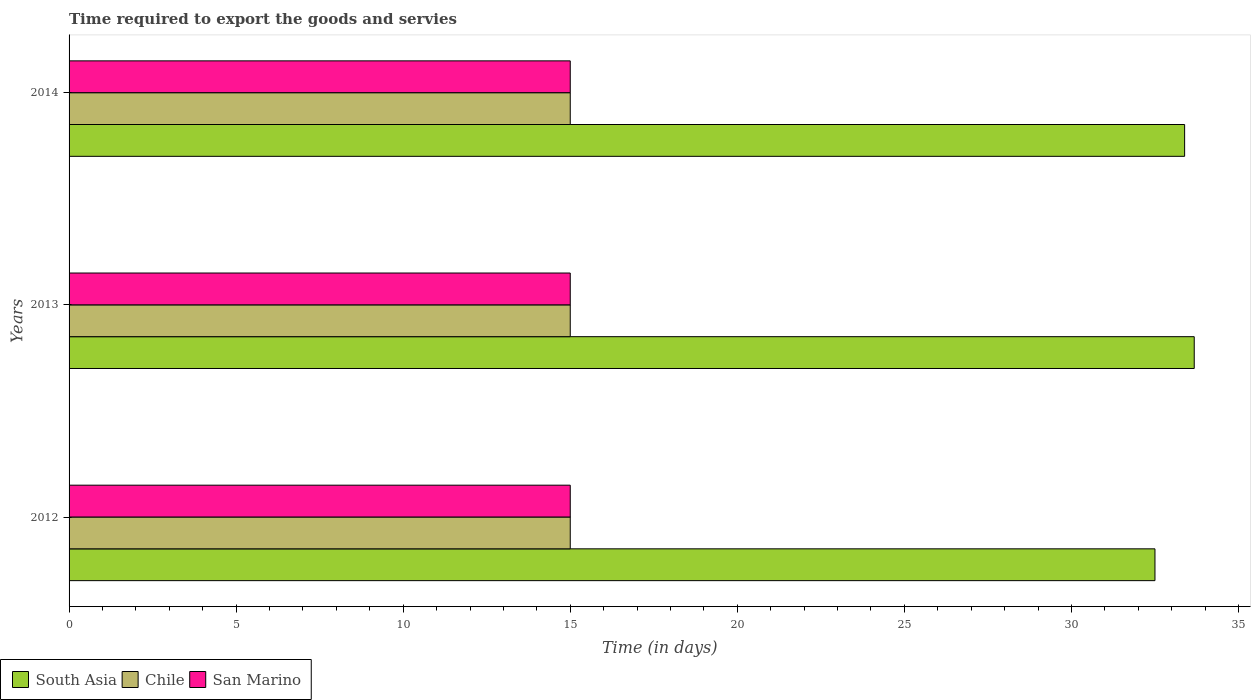How many groups of bars are there?
Keep it short and to the point. 3. Are the number of bars per tick equal to the number of legend labels?
Offer a terse response. Yes. How many bars are there on the 3rd tick from the top?
Ensure brevity in your answer.  3. In how many cases, is the number of bars for a given year not equal to the number of legend labels?
Your response must be concise. 0. What is the number of days required to export the goods and services in South Asia in 2014?
Your answer should be compact. 33.39. Across all years, what is the maximum number of days required to export the goods and services in San Marino?
Offer a terse response. 15. Across all years, what is the minimum number of days required to export the goods and services in South Asia?
Ensure brevity in your answer.  32.5. In which year was the number of days required to export the goods and services in San Marino maximum?
Keep it short and to the point. 2012. What is the difference between the number of days required to export the goods and services in South Asia in 2013 and that in 2014?
Ensure brevity in your answer.  0.29. What is the difference between the number of days required to export the goods and services in Chile in 2013 and the number of days required to export the goods and services in South Asia in 2012?
Your response must be concise. -17.5. What is the ratio of the number of days required to export the goods and services in San Marino in 2012 to that in 2014?
Provide a succinct answer. 1. Is the number of days required to export the goods and services in San Marino in 2012 less than that in 2014?
Provide a succinct answer. No. What is the difference between the highest and the second highest number of days required to export the goods and services in San Marino?
Your response must be concise. 0. What does the 1st bar from the bottom in 2013 represents?
Make the answer very short. South Asia. Are all the bars in the graph horizontal?
Offer a terse response. Yes. What is the difference between two consecutive major ticks on the X-axis?
Provide a short and direct response. 5. Does the graph contain any zero values?
Your answer should be compact. No. What is the title of the graph?
Your answer should be very brief. Time required to export the goods and servies. Does "Dominican Republic" appear as one of the legend labels in the graph?
Your answer should be very brief. No. What is the label or title of the X-axis?
Keep it short and to the point. Time (in days). What is the label or title of the Y-axis?
Offer a very short reply. Years. What is the Time (in days) in South Asia in 2012?
Offer a very short reply. 32.5. What is the Time (in days) of Chile in 2012?
Provide a short and direct response. 15. What is the Time (in days) in San Marino in 2012?
Offer a terse response. 15. What is the Time (in days) in South Asia in 2013?
Ensure brevity in your answer.  33.67. What is the Time (in days) of Chile in 2013?
Make the answer very short. 15. What is the Time (in days) of South Asia in 2014?
Keep it short and to the point. 33.39. Across all years, what is the maximum Time (in days) in South Asia?
Your response must be concise. 33.67. Across all years, what is the minimum Time (in days) in South Asia?
Provide a succinct answer. 32.5. Across all years, what is the minimum Time (in days) of San Marino?
Give a very brief answer. 15. What is the total Time (in days) of South Asia in the graph?
Provide a succinct answer. 99.56. What is the difference between the Time (in days) of South Asia in 2012 and that in 2013?
Provide a succinct answer. -1.18. What is the difference between the Time (in days) of Chile in 2012 and that in 2013?
Offer a terse response. 0. What is the difference between the Time (in days) of San Marino in 2012 and that in 2013?
Keep it short and to the point. 0. What is the difference between the Time (in days) of South Asia in 2012 and that in 2014?
Offer a terse response. -0.89. What is the difference between the Time (in days) in Chile in 2012 and that in 2014?
Your response must be concise. 0. What is the difference between the Time (in days) of South Asia in 2013 and that in 2014?
Give a very brief answer. 0.29. What is the difference between the Time (in days) in Chile in 2013 and that in 2014?
Your response must be concise. 0. What is the difference between the Time (in days) in San Marino in 2013 and that in 2014?
Offer a terse response. 0. What is the difference between the Time (in days) of South Asia in 2012 and the Time (in days) of San Marino in 2013?
Provide a succinct answer. 17.5. What is the difference between the Time (in days) in Chile in 2012 and the Time (in days) in San Marino in 2013?
Provide a short and direct response. 0. What is the difference between the Time (in days) of South Asia in 2012 and the Time (in days) of Chile in 2014?
Your response must be concise. 17.5. What is the difference between the Time (in days) in South Asia in 2013 and the Time (in days) in Chile in 2014?
Make the answer very short. 18.68. What is the difference between the Time (in days) in South Asia in 2013 and the Time (in days) in San Marino in 2014?
Ensure brevity in your answer.  18.68. What is the difference between the Time (in days) in Chile in 2013 and the Time (in days) in San Marino in 2014?
Provide a succinct answer. 0. What is the average Time (in days) in South Asia per year?
Make the answer very short. 33.19. What is the average Time (in days) of Chile per year?
Your answer should be compact. 15. What is the average Time (in days) of San Marino per year?
Your answer should be very brief. 15. In the year 2012, what is the difference between the Time (in days) in South Asia and Time (in days) in San Marino?
Provide a succinct answer. 17.5. In the year 2012, what is the difference between the Time (in days) in Chile and Time (in days) in San Marino?
Make the answer very short. 0. In the year 2013, what is the difference between the Time (in days) of South Asia and Time (in days) of Chile?
Provide a short and direct response. 18.68. In the year 2013, what is the difference between the Time (in days) of South Asia and Time (in days) of San Marino?
Make the answer very short. 18.68. In the year 2014, what is the difference between the Time (in days) of South Asia and Time (in days) of Chile?
Offer a very short reply. 18.39. In the year 2014, what is the difference between the Time (in days) in South Asia and Time (in days) in San Marino?
Make the answer very short. 18.39. In the year 2014, what is the difference between the Time (in days) of Chile and Time (in days) of San Marino?
Your answer should be very brief. 0. What is the ratio of the Time (in days) of South Asia in 2012 to that in 2013?
Give a very brief answer. 0.97. What is the ratio of the Time (in days) in Chile in 2012 to that in 2013?
Keep it short and to the point. 1. What is the ratio of the Time (in days) of San Marino in 2012 to that in 2013?
Give a very brief answer. 1. What is the ratio of the Time (in days) in South Asia in 2012 to that in 2014?
Ensure brevity in your answer.  0.97. What is the ratio of the Time (in days) of Chile in 2012 to that in 2014?
Offer a very short reply. 1. What is the ratio of the Time (in days) of San Marino in 2012 to that in 2014?
Offer a terse response. 1. What is the ratio of the Time (in days) of South Asia in 2013 to that in 2014?
Provide a succinct answer. 1.01. What is the ratio of the Time (in days) in San Marino in 2013 to that in 2014?
Provide a succinct answer. 1. What is the difference between the highest and the second highest Time (in days) of South Asia?
Make the answer very short. 0.29. What is the difference between the highest and the second highest Time (in days) of Chile?
Offer a very short reply. 0. What is the difference between the highest and the second highest Time (in days) of San Marino?
Give a very brief answer. 0. What is the difference between the highest and the lowest Time (in days) of South Asia?
Provide a short and direct response. 1.18. 